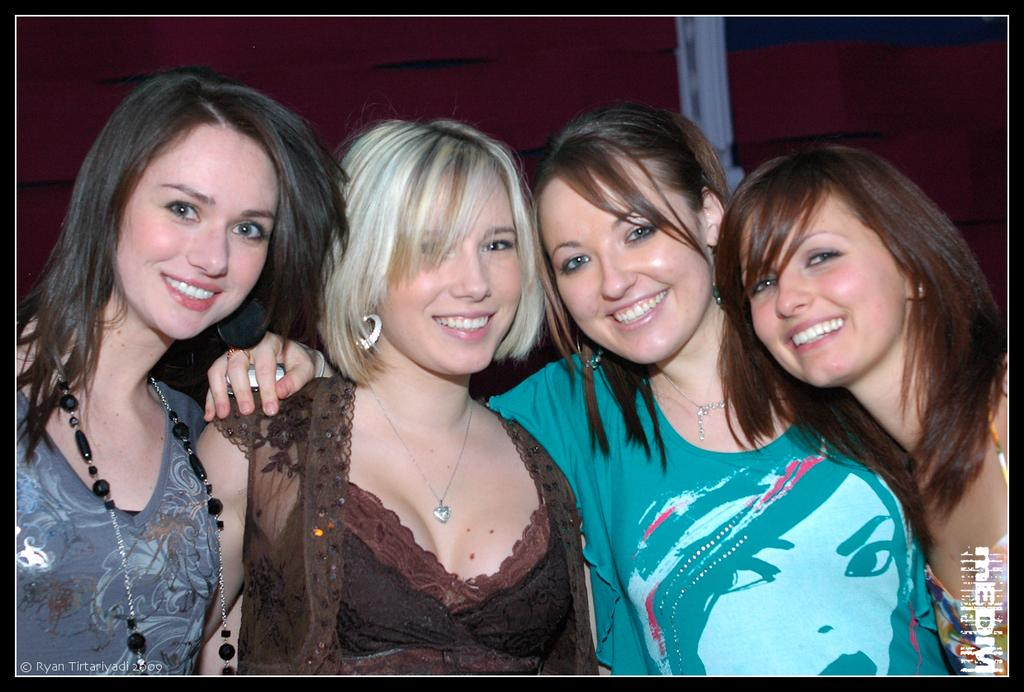How many women are in the image? There are four women in the image. What are the women doing in the image? The women are standing. What can be observed about the women's clothing? The women are wearing different color dresses. What color cloth can be seen in the background? There is a maroon color cloth visible in the background. What type of drug is being grown on the plant in the image? There is no plant or drug present in the image; it features four women standing and wearing different color dresses. 